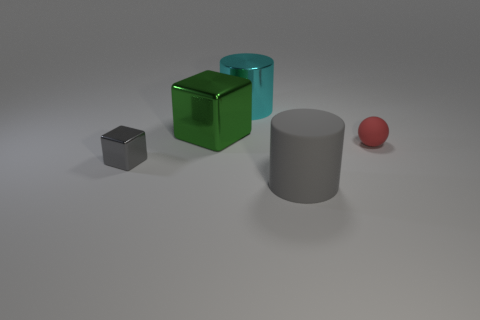Are there any other things that are the same shape as the red object?
Provide a short and direct response. No. How many objects are both in front of the red ball and right of the shiny cylinder?
Your response must be concise. 1. How many other things are the same size as the gray matte cylinder?
Provide a short and direct response. 2. There is a thing that is behind the small gray object and in front of the big green block; what material is it?
Give a very brief answer. Rubber. Is the color of the big rubber thing the same as the tiny thing in front of the rubber sphere?
Your response must be concise. Yes. There is another thing that is the same shape as the green metallic object; what size is it?
Offer a very short reply. Small. What shape is the object that is both behind the gray rubber thing and to the right of the big cyan cylinder?
Keep it short and to the point. Sphere. There is a cyan object; is it the same size as the metallic cube in front of the green shiny cube?
Your answer should be compact. No. What color is the other thing that is the same shape as the gray shiny thing?
Keep it short and to the point. Green. There is a gray object that is on the right side of the small shiny thing; is it the same size as the green metal thing that is to the left of the metallic cylinder?
Your response must be concise. Yes. 